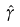Convert formula to latex. <formula><loc_0><loc_0><loc_500><loc_500>\hat { \gamma }</formula> 